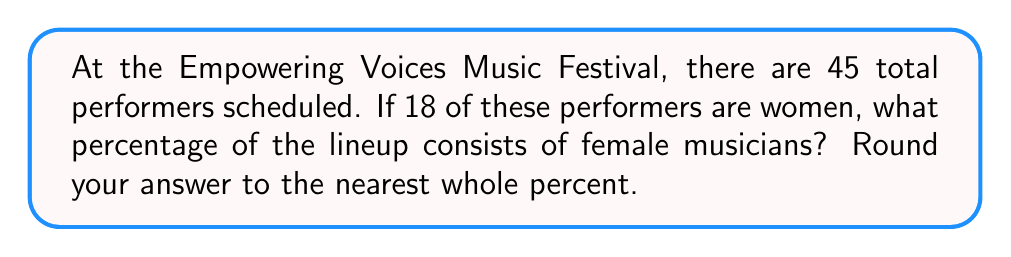Can you answer this question? Let's approach this step-by-step:

1. Identify the given information:
   - Total number of performers: 45
   - Number of female performers: 18

2. To calculate the percentage, we use the formula:
   $$ \text{Percentage} = \frac{\text{Part}}{\text{Whole}} \times 100\% $$

3. In this case:
   - Part = Number of female performers = 18
   - Whole = Total number of performers = 45

4. Let's substitute these values into our formula:
   $$ \text{Percentage of female performers} = \frac{18}{45} \times 100\% $$

5. Simplify the fraction:
   $$ \frac{18}{45} = \frac{2}{5} = 0.4 $$

6. Multiply by 100%:
   $$ 0.4 \times 100\% = 40\% $$

7. The question asks to round to the nearest whole percent, but 40% is already a whole number, so no further rounding is necessary.

Therefore, 40% of the lineup consists of female musicians.
Answer: 40% 